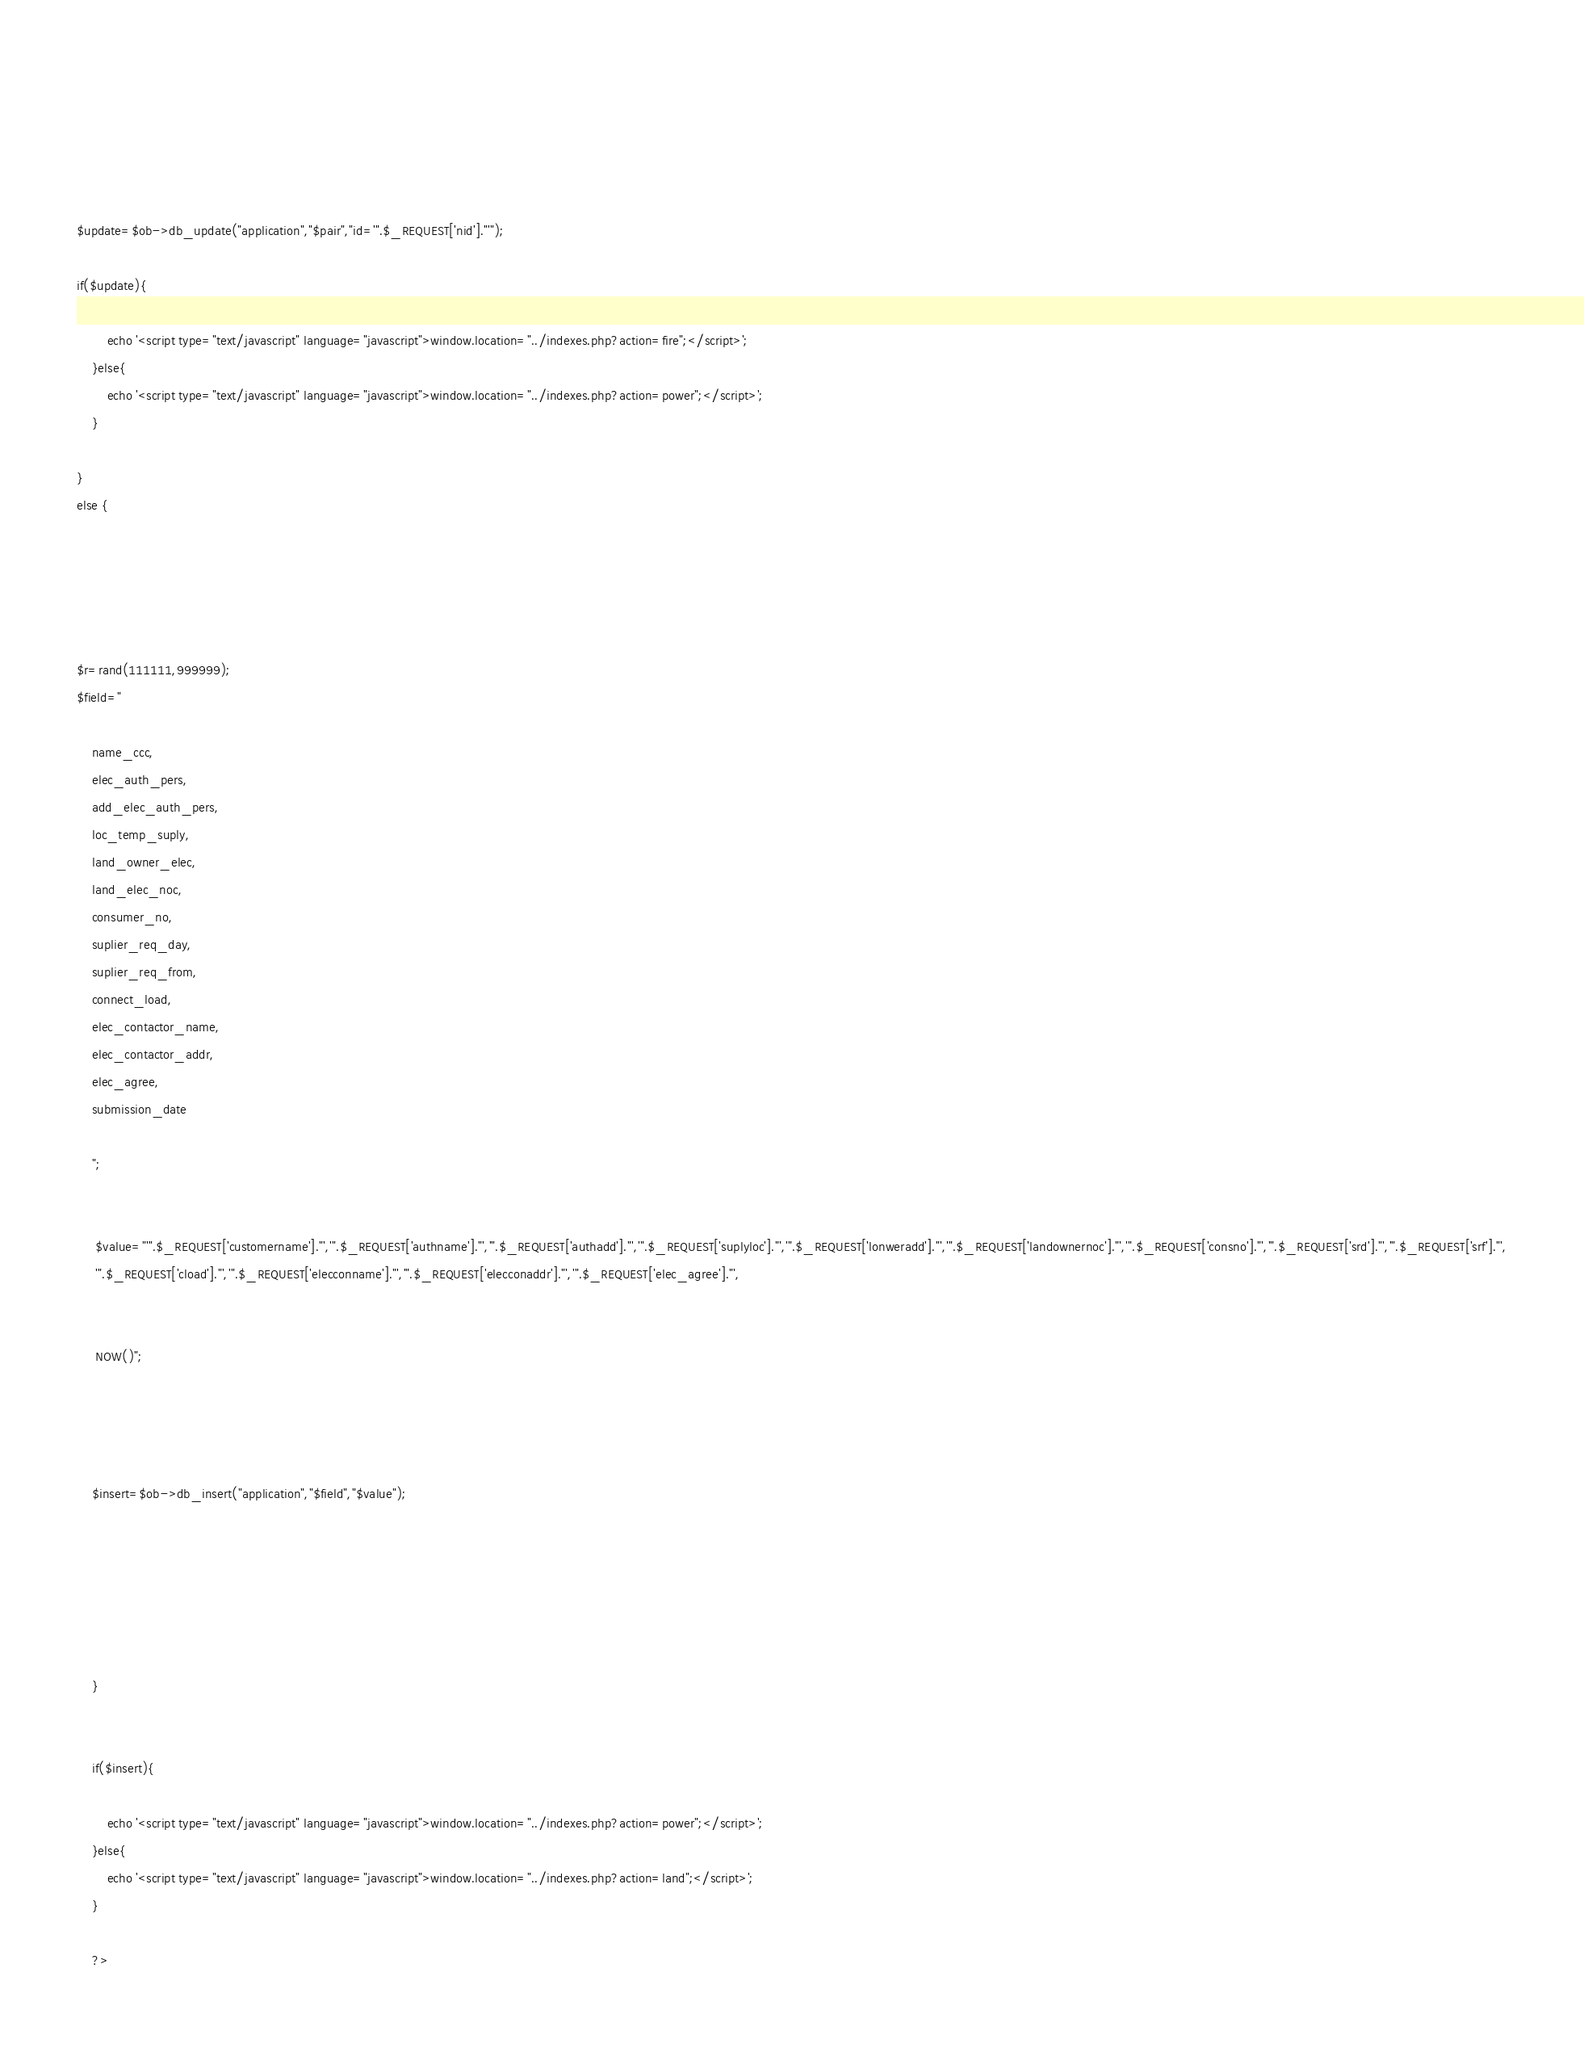Convert code to text. <code><loc_0><loc_0><loc_500><loc_500><_PHP_>





















	
	
 

	 
$update=$ob->db_update("application","$pair","id='".$_REQUEST['nid']."'");
	
if($update){
	
		echo '<script type="text/javascript" language="javascript">window.location="../indexes.php?action=fire";</script>';
	}else{
		echo '<script type="text/javascript" language="javascript">window.location="../indexes.php?action=power";</script>';
	}

}
else {
 
 

 
 
$r=rand(111111,999999);
$field="
	
	name_ccc,
	elec_auth_pers,
	add_elec_auth_pers,
	loc_temp_suply,
	land_owner_elec,
	land_elec_noc,
	consumer_no,
	suplier_req_day,
	suplier_req_from,
	connect_load,
	elec_contactor_name,
	elec_contactor_addr,
	elec_agree,
	submission_date
	
	";	
 

	 $value="'".$_REQUEST['customername']."','".$_REQUEST['authname']."','".$_REQUEST['authadd']."','".$_REQUEST['suplyloc']."','".$_REQUEST['lonweradd']."','".$_REQUEST['landownernoc']."','".$_REQUEST['consno']."','".$_REQUEST['srd']."','".$_REQUEST['srf']."',
	 '".$_REQUEST['cload']."','".$_REQUEST['elecconname']."','".$_REQUEST['elecconaddr']."','".$_REQUEST['elec_agree']."', 
	 
	 
	 NOW()";
	 

	
	
	$insert=$ob->db_insert("application","$field","$value");	
	



	 
 
	}
	

	if($insert){
	
		echo '<script type="text/javascript" language="javascript">window.location="../indexes.php?action=power";</script>';
	}else{
		echo '<script type="text/javascript" language="javascript">window.location="../indexes.php?action=land";</script>';
	}
	
	?></code> 